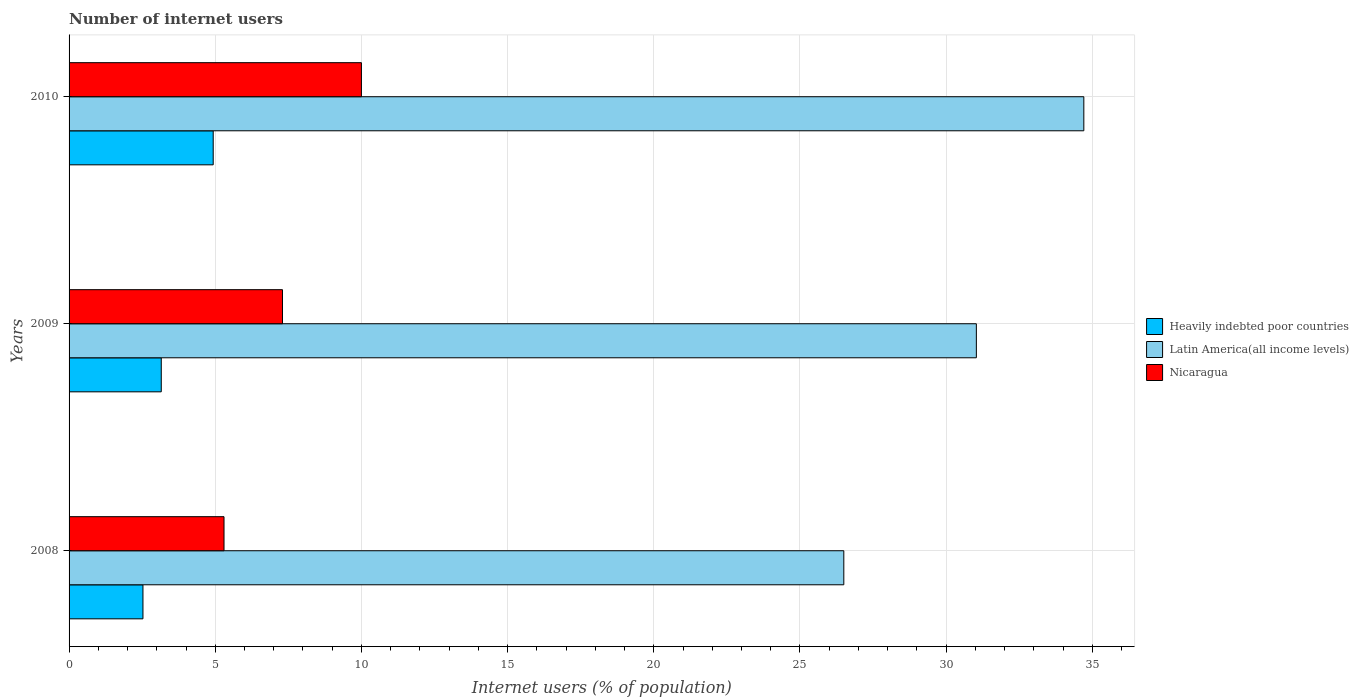How many different coloured bars are there?
Keep it short and to the point. 3. How many groups of bars are there?
Your answer should be compact. 3. Are the number of bars per tick equal to the number of legend labels?
Your answer should be compact. Yes. How many bars are there on the 3rd tick from the top?
Keep it short and to the point. 3. What is the number of internet users in Latin America(all income levels) in 2008?
Provide a short and direct response. 26.5. Across all years, what is the maximum number of internet users in Heavily indebted poor countries?
Provide a succinct answer. 4.93. Across all years, what is the minimum number of internet users in Latin America(all income levels)?
Your answer should be very brief. 26.5. In which year was the number of internet users in Latin America(all income levels) maximum?
Make the answer very short. 2010. In which year was the number of internet users in Heavily indebted poor countries minimum?
Your answer should be very brief. 2008. What is the total number of internet users in Latin America(all income levels) in the graph?
Offer a very short reply. 92.24. What is the difference between the number of internet users in Heavily indebted poor countries in 2008 and that in 2009?
Your answer should be very brief. -0.63. What is the difference between the number of internet users in Latin America(all income levels) in 2010 and the number of internet users in Nicaragua in 2008?
Offer a very short reply. 29.41. What is the average number of internet users in Latin America(all income levels) per year?
Ensure brevity in your answer.  30.75. In the year 2009, what is the difference between the number of internet users in Latin America(all income levels) and number of internet users in Heavily indebted poor countries?
Your answer should be very brief. 27.88. In how many years, is the number of internet users in Nicaragua greater than 17 %?
Make the answer very short. 0. What is the ratio of the number of internet users in Nicaragua in 2008 to that in 2010?
Ensure brevity in your answer.  0.53. Is the number of internet users in Heavily indebted poor countries in 2008 less than that in 2009?
Your answer should be very brief. Yes. What is the difference between the highest and the lowest number of internet users in Latin America(all income levels)?
Your answer should be compact. 8.21. Is the sum of the number of internet users in Heavily indebted poor countries in 2008 and 2010 greater than the maximum number of internet users in Nicaragua across all years?
Your response must be concise. No. What does the 1st bar from the top in 2009 represents?
Your answer should be compact. Nicaragua. What does the 1st bar from the bottom in 2008 represents?
Offer a very short reply. Heavily indebted poor countries. Is it the case that in every year, the sum of the number of internet users in Nicaragua and number of internet users in Heavily indebted poor countries is greater than the number of internet users in Latin America(all income levels)?
Your response must be concise. No. How many years are there in the graph?
Keep it short and to the point. 3. What is the difference between two consecutive major ticks on the X-axis?
Provide a succinct answer. 5. Are the values on the major ticks of X-axis written in scientific E-notation?
Your answer should be compact. No. Does the graph contain any zero values?
Give a very brief answer. No. Does the graph contain grids?
Keep it short and to the point. Yes. Where does the legend appear in the graph?
Your answer should be very brief. Center right. What is the title of the graph?
Your answer should be compact. Number of internet users. What is the label or title of the X-axis?
Your answer should be compact. Internet users (% of population). What is the label or title of the Y-axis?
Offer a very short reply. Years. What is the Internet users (% of population) of Heavily indebted poor countries in 2008?
Your answer should be very brief. 2.53. What is the Internet users (% of population) in Latin America(all income levels) in 2008?
Provide a short and direct response. 26.5. What is the Internet users (% of population) in Nicaragua in 2008?
Your response must be concise. 5.3. What is the Internet users (% of population) of Heavily indebted poor countries in 2009?
Your response must be concise. 3.15. What is the Internet users (% of population) of Latin America(all income levels) in 2009?
Provide a short and direct response. 31.03. What is the Internet users (% of population) of Heavily indebted poor countries in 2010?
Your answer should be very brief. 4.93. What is the Internet users (% of population) of Latin America(all income levels) in 2010?
Offer a very short reply. 34.71. What is the Internet users (% of population) of Nicaragua in 2010?
Give a very brief answer. 10. Across all years, what is the maximum Internet users (% of population) of Heavily indebted poor countries?
Keep it short and to the point. 4.93. Across all years, what is the maximum Internet users (% of population) in Latin America(all income levels)?
Make the answer very short. 34.71. Across all years, what is the maximum Internet users (% of population) in Nicaragua?
Keep it short and to the point. 10. Across all years, what is the minimum Internet users (% of population) of Heavily indebted poor countries?
Offer a very short reply. 2.53. Across all years, what is the minimum Internet users (% of population) of Latin America(all income levels)?
Your answer should be compact. 26.5. Across all years, what is the minimum Internet users (% of population) in Nicaragua?
Offer a very short reply. 5.3. What is the total Internet users (% of population) of Heavily indebted poor countries in the graph?
Your response must be concise. 10.61. What is the total Internet users (% of population) of Latin America(all income levels) in the graph?
Your answer should be very brief. 92.25. What is the total Internet users (% of population) of Nicaragua in the graph?
Provide a succinct answer. 22.6. What is the difference between the Internet users (% of population) in Heavily indebted poor countries in 2008 and that in 2009?
Provide a short and direct response. -0.63. What is the difference between the Internet users (% of population) in Latin America(all income levels) in 2008 and that in 2009?
Provide a succinct answer. -4.53. What is the difference between the Internet users (% of population) in Heavily indebted poor countries in 2008 and that in 2010?
Offer a terse response. -2.4. What is the difference between the Internet users (% of population) in Latin America(all income levels) in 2008 and that in 2010?
Give a very brief answer. -8.21. What is the difference between the Internet users (% of population) in Nicaragua in 2008 and that in 2010?
Offer a terse response. -4.7. What is the difference between the Internet users (% of population) of Heavily indebted poor countries in 2009 and that in 2010?
Your answer should be compact. -1.78. What is the difference between the Internet users (% of population) in Latin America(all income levels) in 2009 and that in 2010?
Make the answer very short. -3.68. What is the difference between the Internet users (% of population) in Nicaragua in 2009 and that in 2010?
Your response must be concise. -2.7. What is the difference between the Internet users (% of population) of Heavily indebted poor countries in 2008 and the Internet users (% of population) of Latin America(all income levels) in 2009?
Offer a very short reply. -28.51. What is the difference between the Internet users (% of population) of Heavily indebted poor countries in 2008 and the Internet users (% of population) of Nicaragua in 2009?
Provide a succinct answer. -4.77. What is the difference between the Internet users (% of population) in Latin America(all income levels) in 2008 and the Internet users (% of population) in Nicaragua in 2009?
Your answer should be compact. 19.2. What is the difference between the Internet users (% of population) in Heavily indebted poor countries in 2008 and the Internet users (% of population) in Latin America(all income levels) in 2010?
Your answer should be compact. -32.18. What is the difference between the Internet users (% of population) of Heavily indebted poor countries in 2008 and the Internet users (% of population) of Nicaragua in 2010?
Keep it short and to the point. -7.47. What is the difference between the Internet users (% of population) of Latin America(all income levels) in 2008 and the Internet users (% of population) of Nicaragua in 2010?
Your answer should be compact. 16.5. What is the difference between the Internet users (% of population) in Heavily indebted poor countries in 2009 and the Internet users (% of population) in Latin America(all income levels) in 2010?
Offer a terse response. -31.56. What is the difference between the Internet users (% of population) in Heavily indebted poor countries in 2009 and the Internet users (% of population) in Nicaragua in 2010?
Provide a short and direct response. -6.85. What is the difference between the Internet users (% of population) in Latin America(all income levels) in 2009 and the Internet users (% of population) in Nicaragua in 2010?
Your response must be concise. 21.03. What is the average Internet users (% of population) of Heavily indebted poor countries per year?
Your response must be concise. 3.54. What is the average Internet users (% of population) of Latin America(all income levels) per year?
Your response must be concise. 30.75. What is the average Internet users (% of population) of Nicaragua per year?
Your answer should be very brief. 7.53. In the year 2008, what is the difference between the Internet users (% of population) of Heavily indebted poor countries and Internet users (% of population) of Latin America(all income levels)?
Provide a succinct answer. -23.97. In the year 2008, what is the difference between the Internet users (% of population) in Heavily indebted poor countries and Internet users (% of population) in Nicaragua?
Make the answer very short. -2.77. In the year 2008, what is the difference between the Internet users (% of population) in Latin America(all income levels) and Internet users (% of population) in Nicaragua?
Ensure brevity in your answer.  21.2. In the year 2009, what is the difference between the Internet users (% of population) of Heavily indebted poor countries and Internet users (% of population) of Latin America(all income levels)?
Offer a terse response. -27.88. In the year 2009, what is the difference between the Internet users (% of population) of Heavily indebted poor countries and Internet users (% of population) of Nicaragua?
Ensure brevity in your answer.  -4.15. In the year 2009, what is the difference between the Internet users (% of population) in Latin America(all income levels) and Internet users (% of population) in Nicaragua?
Your answer should be very brief. 23.73. In the year 2010, what is the difference between the Internet users (% of population) of Heavily indebted poor countries and Internet users (% of population) of Latin America(all income levels)?
Offer a very short reply. -29.78. In the year 2010, what is the difference between the Internet users (% of population) in Heavily indebted poor countries and Internet users (% of population) in Nicaragua?
Your answer should be very brief. -5.07. In the year 2010, what is the difference between the Internet users (% of population) of Latin America(all income levels) and Internet users (% of population) of Nicaragua?
Give a very brief answer. 24.71. What is the ratio of the Internet users (% of population) in Heavily indebted poor countries in 2008 to that in 2009?
Give a very brief answer. 0.8. What is the ratio of the Internet users (% of population) in Latin America(all income levels) in 2008 to that in 2009?
Your answer should be compact. 0.85. What is the ratio of the Internet users (% of population) of Nicaragua in 2008 to that in 2009?
Your answer should be very brief. 0.73. What is the ratio of the Internet users (% of population) in Heavily indebted poor countries in 2008 to that in 2010?
Provide a short and direct response. 0.51. What is the ratio of the Internet users (% of population) in Latin America(all income levels) in 2008 to that in 2010?
Your answer should be compact. 0.76. What is the ratio of the Internet users (% of population) of Nicaragua in 2008 to that in 2010?
Keep it short and to the point. 0.53. What is the ratio of the Internet users (% of population) of Heavily indebted poor countries in 2009 to that in 2010?
Offer a very short reply. 0.64. What is the ratio of the Internet users (% of population) in Latin America(all income levels) in 2009 to that in 2010?
Make the answer very short. 0.89. What is the ratio of the Internet users (% of population) in Nicaragua in 2009 to that in 2010?
Ensure brevity in your answer.  0.73. What is the difference between the highest and the second highest Internet users (% of population) in Heavily indebted poor countries?
Provide a short and direct response. 1.78. What is the difference between the highest and the second highest Internet users (% of population) of Latin America(all income levels)?
Give a very brief answer. 3.68. What is the difference between the highest and the lowest Internet users (% of population) of Heavily indebted poor countries?
Your response must be concise. 2.4. What is the difference between the highest and the lowest Internet users (% of population) in Latin America(all income levels)?
Your answer should be very brief. 8.21. 